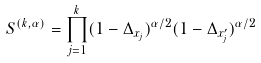Convert formula to latex. <formula><loc_0><loc_0><loc_500><loc_500>S ^ { ( k , \alpha ) } = \prod _ { j = 1 } ^ { k } ( 1 - \Delta _ { x _ { j } } ) ^ { \alpha / 2 } ( 1 - \Delta _ { x ^ { \prime } _ { j } } ) ^ { \alpha / 2 }</formula> 